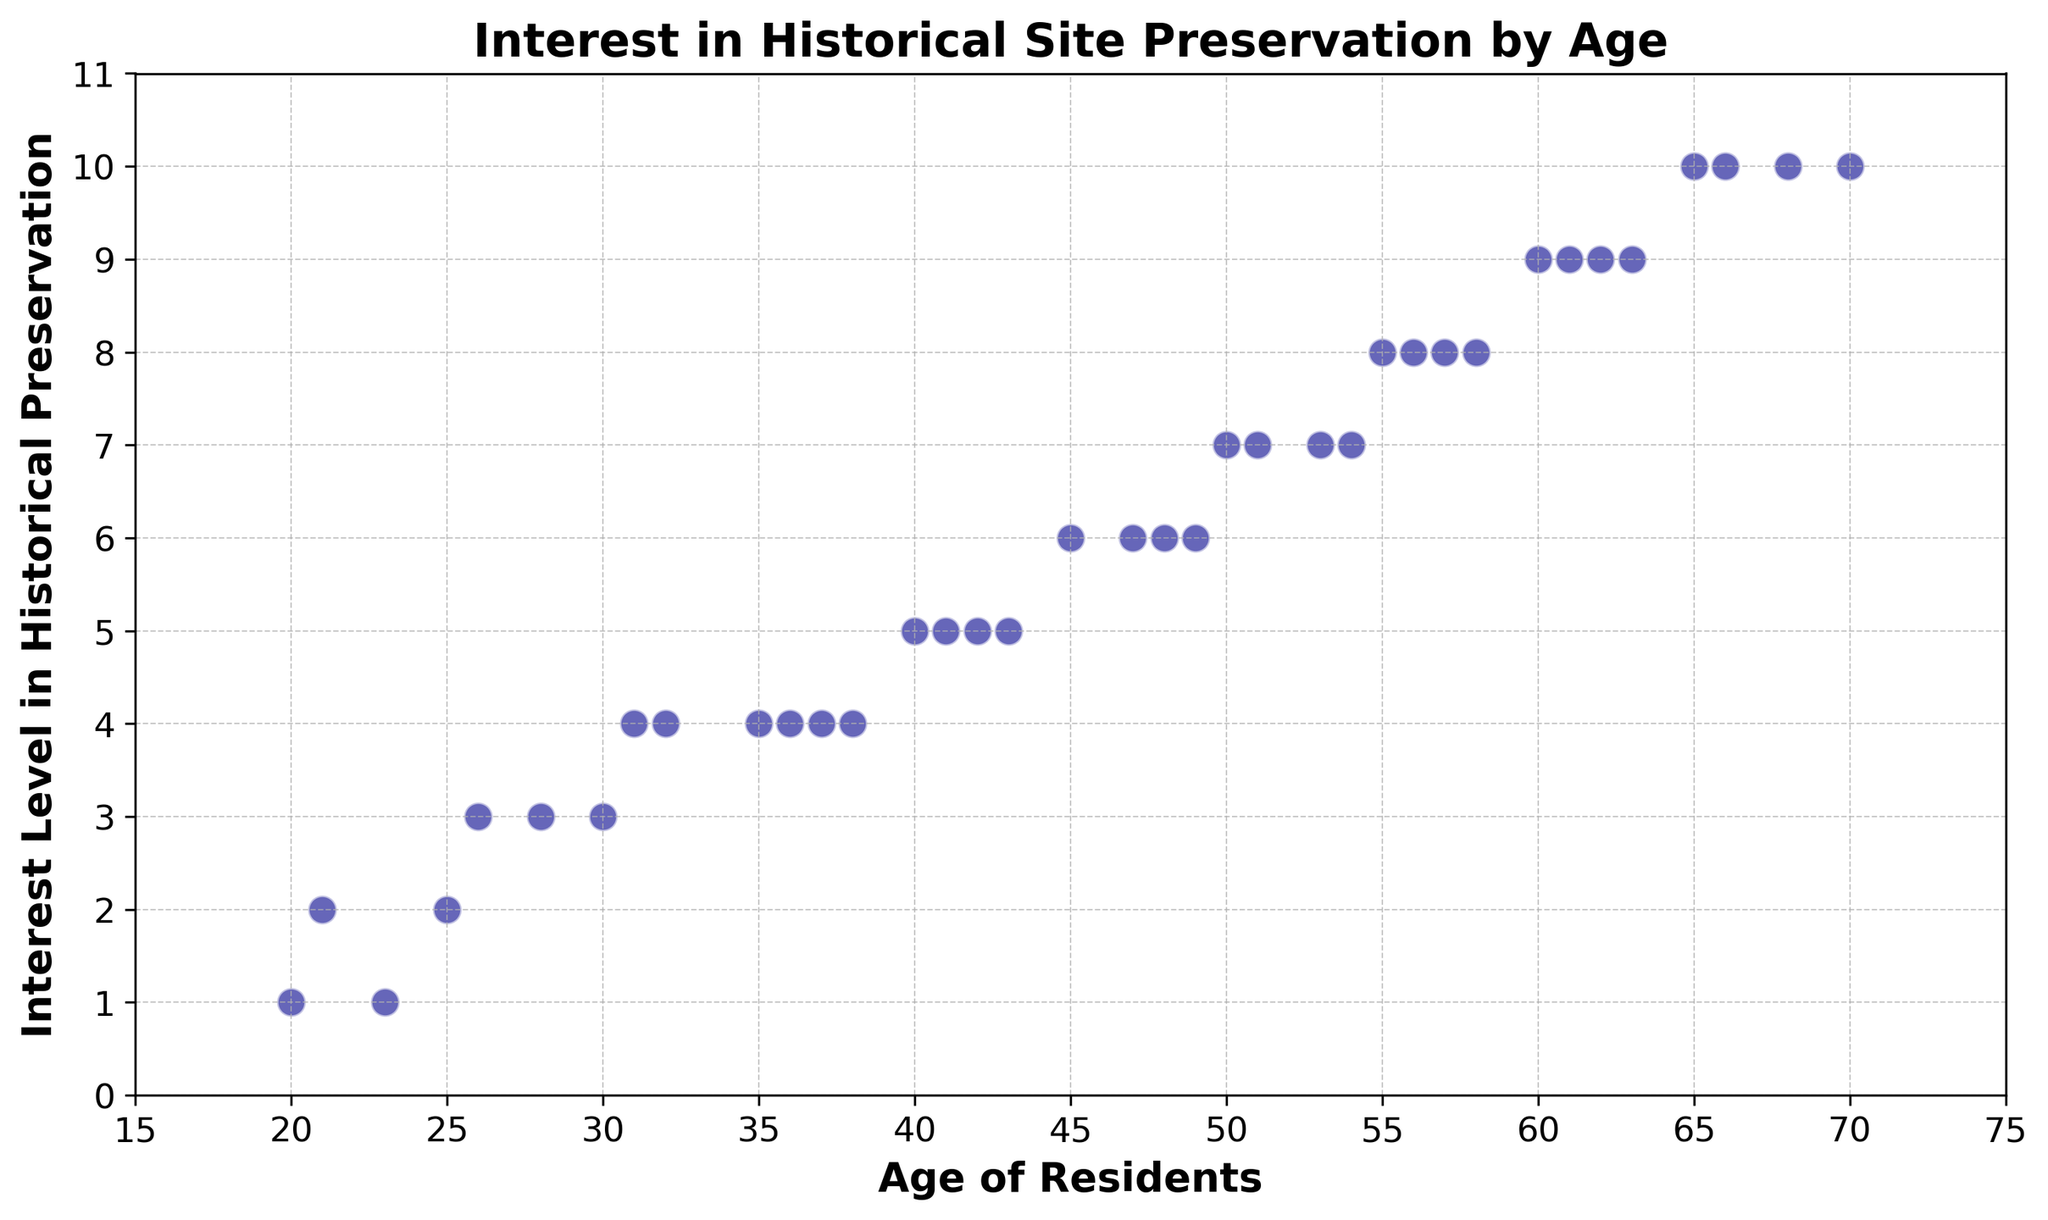Which age group shows the highest interest in historical site preservation? The highest interest level is 10, and it corresponds to ages 65, 68, 70, and 66.
Answer: Ages 65, 68, 70, 66 Is there an age group with an interest level of 1? The lowest interest level is 1, corresponding to ages 23 and 20.
Answer: Ages 23, 20 What’s the average interest level for residents aged between 40 and 50 (inclusive)? The interest levels are 5 (age 40), 5 (41), 6 (47), and 6 (48). The average = (5 + 5 + 6 + 6) / 4 = 5.5.
Answer: 5.5 Do residents in their 60s generally show more interest compared to those in their 20s? The interest levels for ages 60, 62, 61, 63, and 66 (in their 60s) are 9, 9, 9, 9, and 10 respectively, showing generally high interest. The interest levels for ages 20, 21, 23, 25, 26, and 28 (in their 20s) are 1, 2, 1, 2, 3, and 3, showing generally lower interest.
Answer: Yes How does the interest level change as we move from the youngest to the oldest age group in the plot? The interest level generally increases from the youngest age group (20s) with low interest levels (1 to 3) to the oldest age group (60s and 70s) with high interest levels (9 and 10).
Answer: Increases Is there a noticeable pattern in the relationship between age and interest level? Observing the scatter plot, interest levels tend to gradually increase with age. Younger individuals exhibit lower interest levels, while older individuals show higher interest levels consistently.
Answer: Yes, interest levels increase with age What’s the range of interest levels shown by residents aged 30 to 40? The interest levels for ages between 30 and 40 are 3 (30), 4 (35), 4 (37), 4 (38), 4 (36), and 5 (40). The range is the difference between the highest (5) and the lowest (3) interest levels, which is 5 - 3.
Answer: 2 